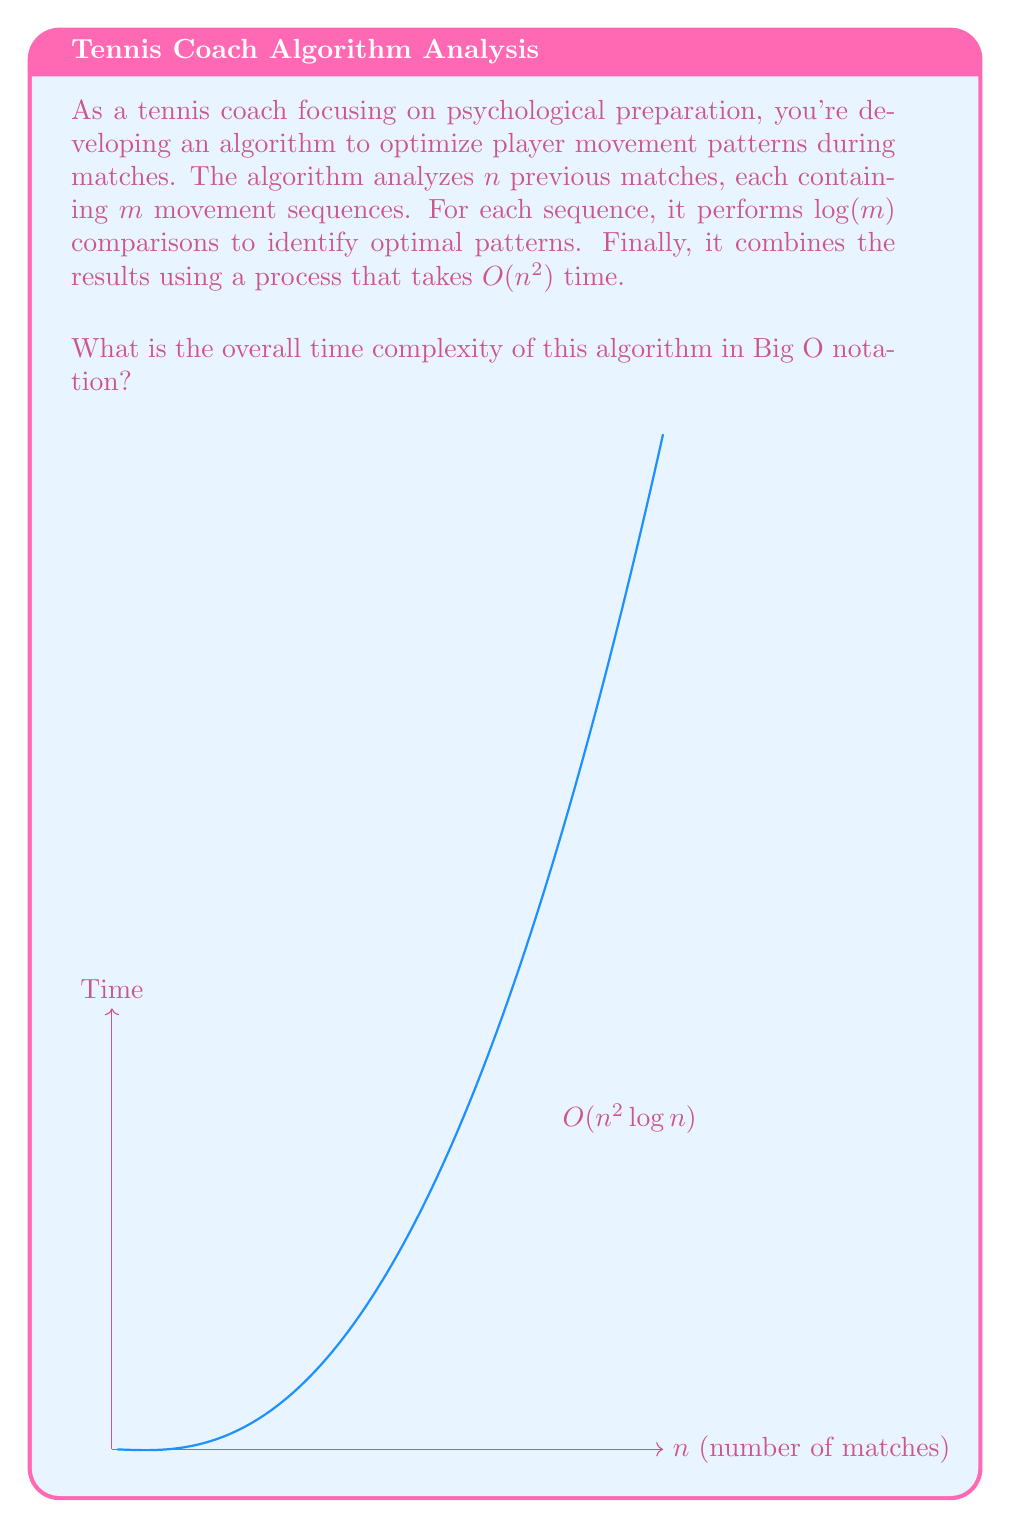Give your solution to this math problem. Let's break down the algorithm and analyze its time complexity step by step:

1) The algorithm analyzes $n$ previous matches.

2) For each match, it processes $m$ movement sequences.

3) For each sequence, it performs $\log(m)$ comparisons.

4) Steps 2 and 3 combined give us: $m \cdot \log(m)$ operations per match.

5) Since this is done for all $n$ matches, we have: $n \cdot (m \cdot \log(m))$ operations.

6) Finally, there's a combining process that takes $O(n^2)$ time.

To get the overall time complexity, we need to sum these components:

$$T(n,m) = n \cdot (m \cdot \log(m)) + n^2$$

Now, we need to express this in terms of $n$ only. In Big O notation, we're interested in the upper bound as $n$ grows large. We can assume that $m$ is either constant or grows more slowly than $n$. Therefore, $m \cdot \log(m)$ can be treated as a constant factor.

Simplifying:

$$T(n) = O(n \cdot c + n^2)$$

Where $c$ is some constant.

As $n$ grows large, the $n^2$ term dominates, so we can drop the lower-order term:

$$T(n) = O(n^2)$$

However, we're not done yet. Remember that for each sequence, we perform $\log(m)$ comparisons. If $m$ is related to $n$ in any way (e.g., if $m = n$), we need to account for this logarithmic factor:

$$T(n) = O(n^2 \log n)$$

This is the most conservative (upper bound) estimate of the time complexity.
Answer: $O(n^2 \log n)$ 